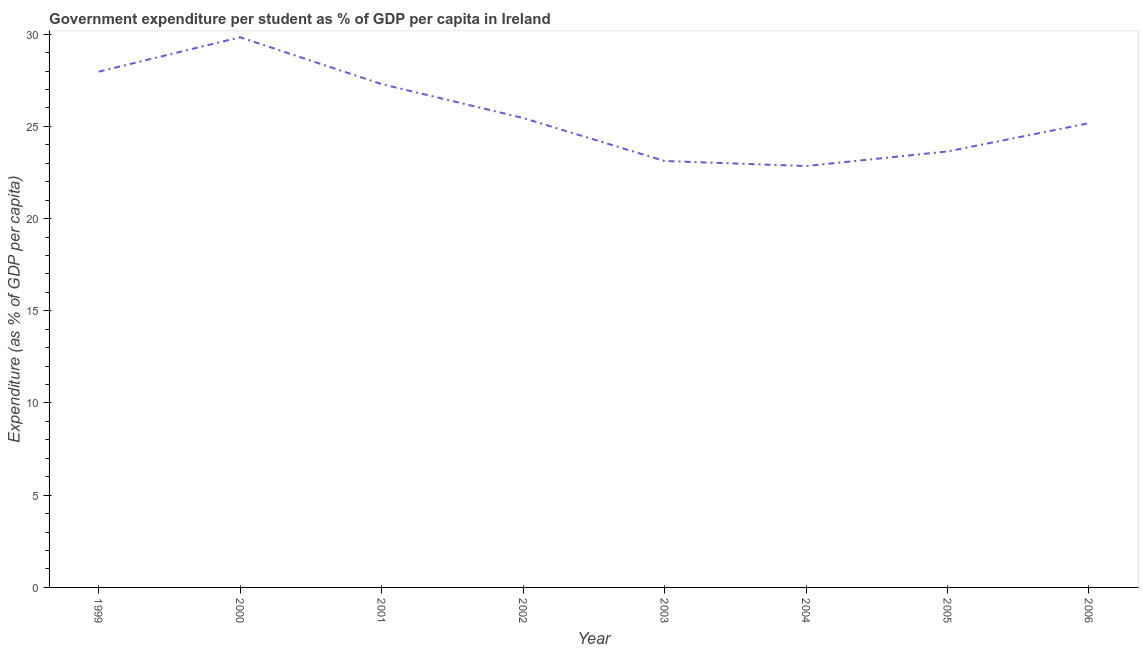What is the government expenditure per student in 2004?
Make the answer very short. 22.85. Across all years, what is the maximum government expenditure per student?
Your answer should be very brief. 29.83. Across all years, what is the minimum government expenditure per student?
Keep it short and to the point. 22.85. What is the sum of the government expenditure per student?
Your answer should be very brief. 205.32. What is the difference between the government expenditure per student in 2003 and 2005?
Give a very brief answer. -0.52. What is the average government expenditure per student per year?
Your response must be concise. 25.67. What is the median government expenditure per student?
Your answer should be compact. 25.31. Do a majority of the years between 2006 and 2004 (inclusive) have government expenditure per student greater than 2 %?
Give a very brief answer. No. What is the ratio of the government expenditure per student in 2002 to that in 2006?
Give a very brief answer. 1.01. Is the government expenditure per student in 2001 less than that in 2006?
Your answer should be compact. No. What is the difference between the highest and the second highest government expenditure per student?
Your response must be concise. 1.86. What is the difference between the highest and the lowest government expenditure per student?
Offer a very short reply. 6.98. In how many years, is the government expenditure per student greater than the average government expenditure per student taken over all years?
Provide a succinct answer. 3. Does the government expenditure per student monotonically increase over the years?
Offer a very short reply. No. How many lines are there?
Make the answer very short. 1. How many years are there in the graph?
Ensure brevity in your answer.  8. Are the values on the major ticks of Y-axis written in scientific E-notation?
Your answer should be compact. No. Does the graph contain any zero values?
Ensure brevity in your answer.  No. Does the graph contain grids?
Offer a terse response. No. What is the title of the graph?
Your answer should be very brief. Government expenditure per student as % of GDP per capita in Ireland. What is the label or title of the Y-axis?
Provide a succinct answer. Expenditure (as % of GDP per capita). What is the Expenditure (as % of GDP per capita) in 1999?
Give a very brief answer. 27.97. What is the Expenditure (as % of GDP per capita) in 2000?
Provide a succinct answer. 29.83. What is the Expenditure (as % of GDP per capita) in 2001?
Provide a succinct answer. 27.29. What is the Expenditure (as % of GDP per capita) of 2002?
Your answer should be very brief. 25.45. What is the Expenditure (as % of GDP per capita) in 2003?
Keep it short and to the point. 23.12. What is the Expenditure (as % of GDP per capita) of 2004?
Provide a succinct answer. 22.85. What is the Expenditure (as % of GDP per capita) in 2005?
Offer a very short reply. 23.64. What is the Expenditure (as % of GDP per capita) of 2006?
Your answer should be very brief. 25.17. What is the difference between the Expenditure (as % of GDP per capita) in 1999 and 2000?
Offer a terse response. -1.86. What is the difference between the Expenditure (as % of GDP per capita) in 1999 and 2001?
Give a very brief answer. 0.67. What is the difference between the Expenditure (as % of GDP per capita) in 1999 and 2002?
Make the answer very short. 2.51. What is the difference between the Expenditure (as % of GDP per capita) in 1999 and 2003?
Offer a terse response. 4.84. What is the difference between the Expenditure (as % of GDP per capita) in 1999 and 2004?
Offer a terse response. 5.12. What is the difference between the Expenditure (as % of GDP per capita) in 1999 and 2005?
Make the answer very short. 4.33. What is the difference between the Expenditure (as % of GDP per capita) in 1999 and 2006?
Provide a succinct answer. 2.79. What is the difference between the Expenditure (as % of GDP per capita) in 2000 and 2001?
Ensure brevity in your answer.  2.54. What is the difference between the Expenditure (as % of GDP per capita) in 2000 and 2002?
Offer a very short reply. 4.38. What is the difference between the Expenditure (as % of GDP per capita) in 2000 and 2003?
Give a very brief answer. 6.71. What is the difference between the Expenditure (as % of GDP per capita) in 2000 and 2004?
Offer a very short reply. 6.98. What is the difference between the Expenditure (as % of GDP per capita) in 2000 and 2005?
Provide a short and direct response. 6.19. What is the difference between the Expenditure (as % of GDP per capita) in 2000 and 2006?
Keep it short and to the point. 4.66. What is the difference between the Expenditure (as % of GDP per capita) in 2001 and 2002?
Keep it short and to the point. 1.84. What is the difference between the Expenditure (as % of GDP per capita) in 2001 and 2003?
Provide a succinct answer. 4.17. What is the difference between the Expenditure (as % of GDP per capita) in 2001 and 2004?
Keep it short and to the point. 4.44. What is the difference between the Expenditure (as % of GDP per capita) in 2001 and 2005?
Provide a short and direct response. 3.65. What is the difference between the Expenditure (as % of GDP per capita) in 2001 and 2006?
Provide a short and direct response. 2.12. What is the difference between the Expenditure (as % of GDP per capita) in 2002 and 2003?
Make the answer very short. 2.33. What is the difference between the Expenditure (as % of GDP per capita) in 2002 and 2004?
Your answer should be compact. 2.61. What is the difference between the Expenditure (as % of GDP per capita) in 2002 and 2005?
Make the answer very short. 1.82. What is the difference between the Expenditure (as % of GDP per capita) in 2002 and 2006?
Provide a short and direct response. 0.28. What is the difference between the Expenditure (as % of GDP per capita) in 2003 and 2004?
Offer a very short reply. 0.27. What is the difference between the Expenditure (as % of GDP per capita) in 2003 and 2005?
Ensure brevity in your answer.  -0.52. What is the difference between the Expenditure (as % of GDP per capita) in 2003 and 2006?
Your answer should be very brief. -2.05. What is the difference between the Expenditure (as % of GDP per capita) in 2004 and 2005?
Your answer should be very brief. -0.79. What is the difference between the Expenditure (as % of GDP per capita) in 2004 and 2006?
Your answer should be very brief. -2.32. What is the difference between the Expenditure (as % of GDP per capita) in 2005 and 2006?
Your answer should be very brief. -1.53. What is the ratio of the Expenditure (as % of GDP per capita) in 1999 to that in 2000?
Offer a terse response. 0.94. What is the ratio of the Expenditure (as % of GDP per capita) in 1999 to that in 2001?
Provide a short and direct response. 1.02. What is the ratio of the Expenditure (as % of GDP per capita) in 1999 to that in 2002?
Ensure brevity in your answer.  1.1. What is the ratio of the Expenditure (as % of GDP per capita) in 1999 to that in 2003?
Provide a succinct answer. 1.21. What is the ratio of the Expenditure (as % of GDP per capita) in 1999 to that in 2004?
Provide a short and direct response. 1.22. What is the ratio of the Expenditure (as % of GDP per capita) in 1999 to that in 2005?
Provide a succinct answer. 1.18. What is the ratio of the Expenditure (as % of GDP per capita) in 1999 to that in 2006?
Provide a short and direct response. 1.11. What is the ratio of the Expenditure (as % of GDP per capita) in 2000 to that in 2001?
Make the answer very short. 1.09. What is the ratio of the Expenditure (as % of GDP per capita) in 2000 to that in 2002?
Provide a succinct answer. 1.17. What is the ratio of the Expenditure (as % of GDP per capita) in 2000 to that in 2003?
Keep it short and to the point. 1.29. What is the ratio of the Expenditure (as % of GDP per capita) in 2000 to that in 2004?
Provide a succinct answer. 1.31. What is the ratio of the Expenditure (as % of GDP per capita) in 2000 to that in 2005?
Your response must be concise. 1.26. What is the ratio of the Expenditure (as % of GDP per capita) in 2000 to that in 2006?
Offer a very short reply. 1.19. What is the ratio of the Expenditure (as % of GDP per capita) in 2001 to that in 2002?
Make the answer very short. 1.07. What is the ratio of the Expenditure (as % of GDP per capita) in 2001 to that in 2003?
Give a very brief answer. 1.18. What is the ratio of the Expenditure (as % of GDP per capita) in 2001 to that in 2004?
Your response must be concise. 1.19. What is the ratio of the Expenditure (as % of GDP per capita) in 2001 to that in 2005?
Provide a short and direct response. 1.16. What is the ratio of the Expenditure (as % of GDP per capita) in 2001 to that in 2006?
Give a very brief answer. 1.08. What is the ratio of the Expenditure (as % of GDP per capita) in 2002 to that in 2003?
Give a very brief answer. 1.1. What is the ratio of the Expenditure (as % of GDP per capita) in 2002 to that in 2004?
Offer a terse response. 1.11. What is the ratio of the Expenditure (as % of GDP per capita) in 2002 to that in 2005?
Your answer should be compact. 1.08. What is the ratio of the Expenditure (as % of GDP per capita) in 2003 to that in 2006?
Give a very brief answer. 0.92. What is the ratio of the Expenditure (as % of GDP per capita) in 2004 to that in 2005?
Provide a succinct answer. 0.97. What is the ratio of the Expenditure (as % of GDP per capita) in 2004 to that in 2006?
Your response must be concise. 0.91. What is the ratio of the Expenditure (as % of GDP per capita) in 2005 to that in 2006?
Offer a very short reply. 0.94. 